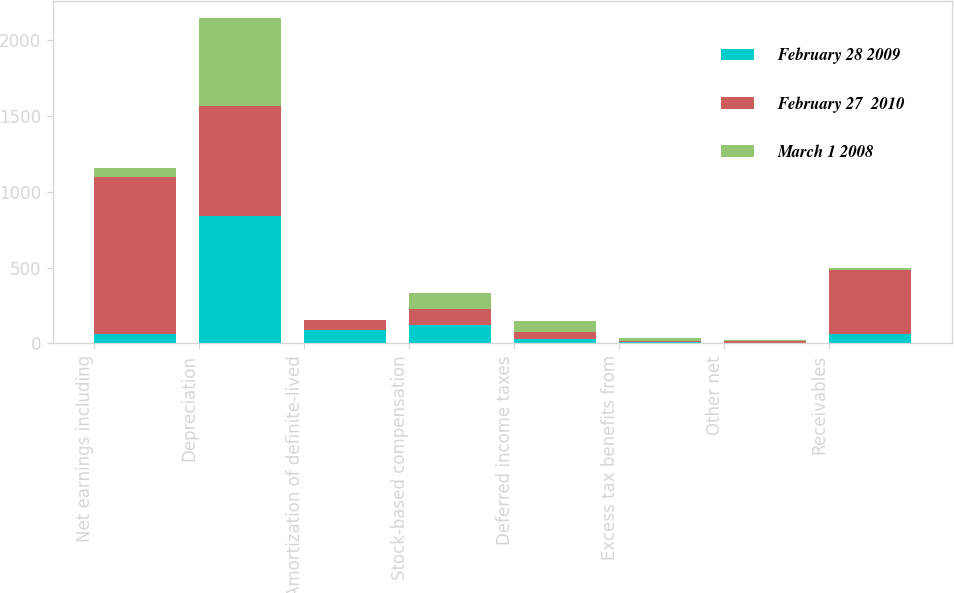Convert chart to OTSL. <chart><loc_0><loc_0><loc_500><loc_500><stacked_bar_chart><ecel><fcel>Net earnings including<fcel>Depreciation<fcel>Amortization of definite-lived<fcel>Stock-based compensation<fcel>Deferred income taxes<fcel>Excess tax benefits from<fcel>Other net<fcel>Receivables<nl><fcel>February 28 2009<fcel>63<fcel>838<fcel>88<fcel>118<fcel>30<fcel>7<fcel>4<fcel>63<nl><fcel>February 27  2010<fcel>1033<fcel>730<fcel>63<fcel>110<fcel>43<fcel>6<fcel>12<fcel>419<nl><fcel>March 1 2008<fcel>63<fcel>580<fcel>1<fcel>105<fcel>74<fcel>24<fcel>7<fcel>12<nl></chart> 